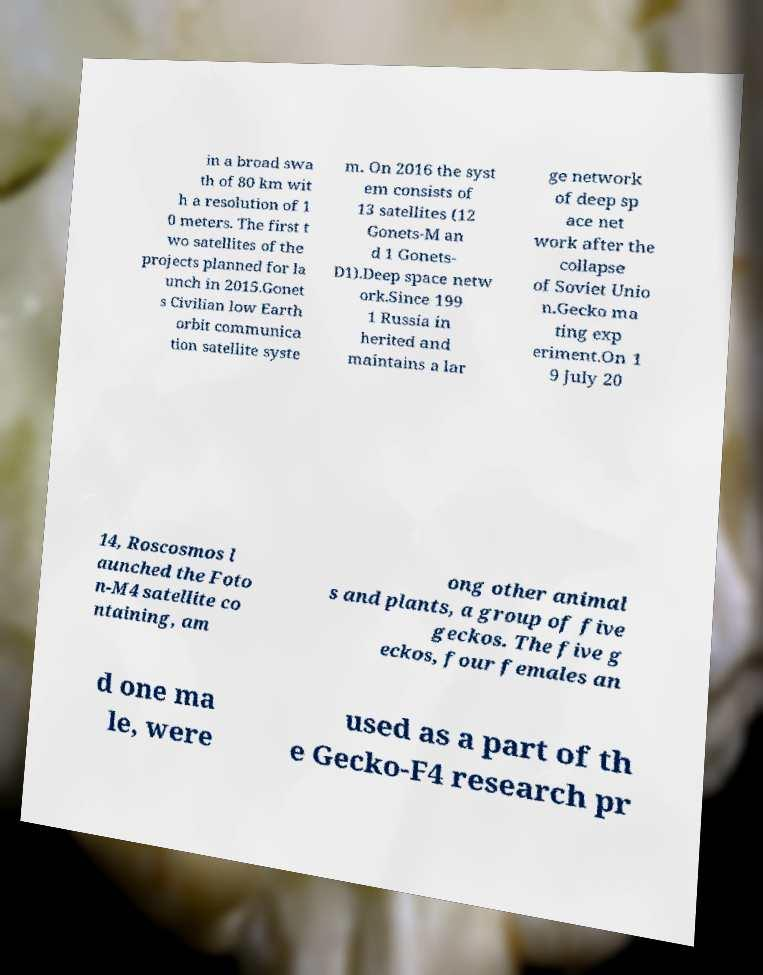Could you assist in decoding the text presented in this image and type it out clearly? in a broad swa th of 80 km wit h a resolution of 1 0 meters. The first t wo satellites of the projects planned for la unch in 2015.Gonet s Civilian low Earth orbit communica tion satellite syste m. On 2016 the syst em consists of 13 satellites (12 Gonets-M an d 1 Gonets- D1).Deep space netw ork.Since 199 1 Russia in herited and maintains a lar ge network of deep sp ace net work after the collapse of Soviet Unio n.Gecko ma ting exp eriment.On 1 9 July 20 14, Roscosmos l aunched the Foto n-M4 satellite co ntaining, am ong other animal s and plants, a group of five geckos. The five g eckos, four females an d one ma le, were used as a part of th e Gecko-F4 research pr 